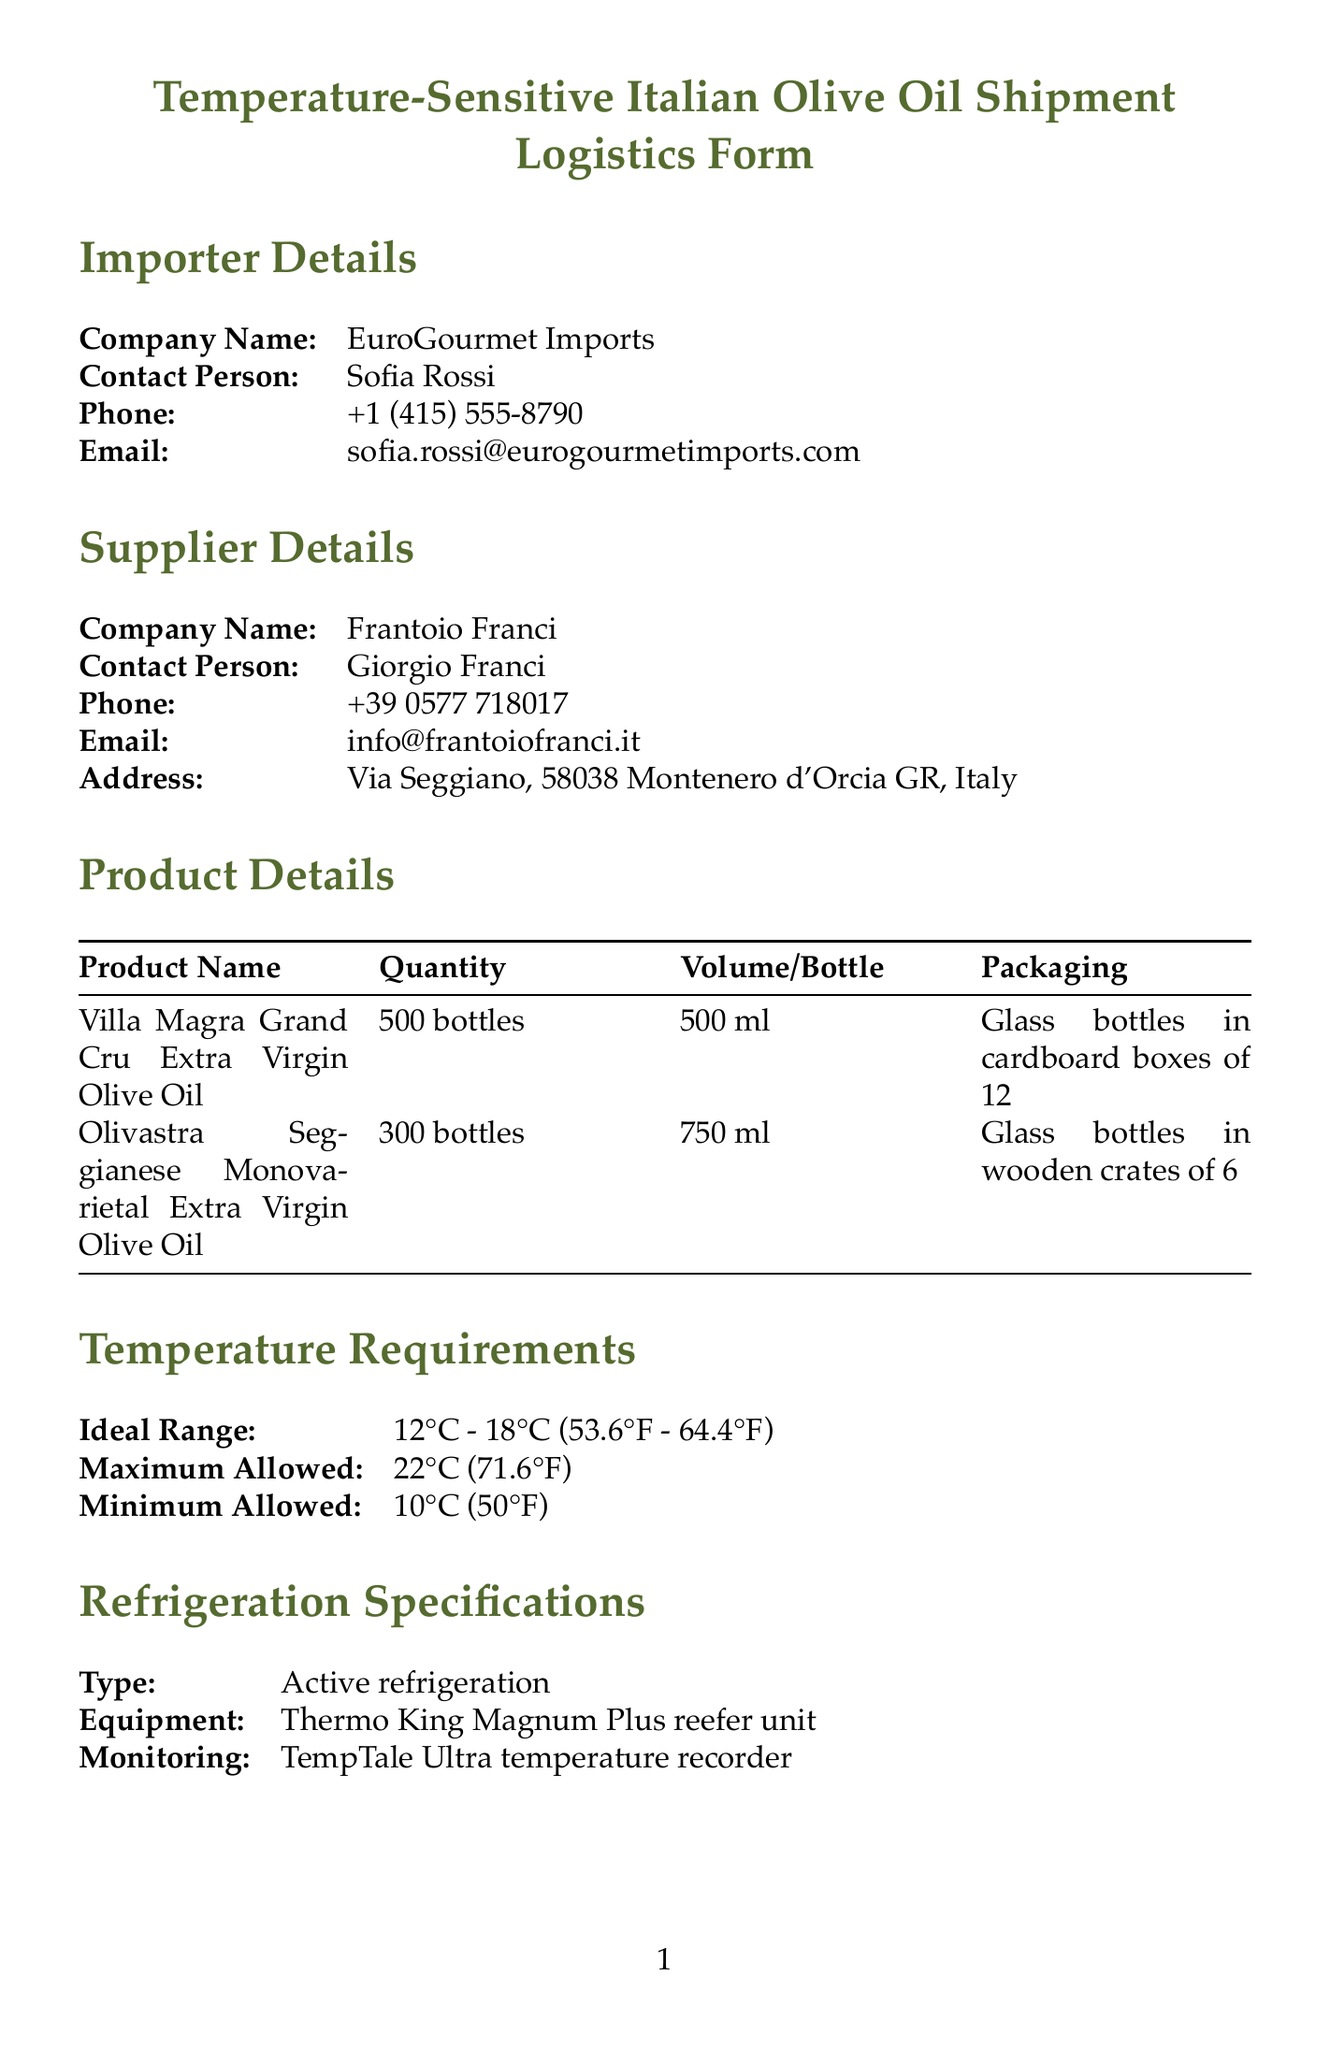What is the company name of the importer? The importer details section provides the company's name as EuroGourmet Imports.
Answer: EuroGourmet Imports Who is the contact person at the supplier's company? The supplier details section lists Giorgio Franci as the contact person.
Answer: Giorgio Franci What is the ideal temperature range for the olive oil shipment? The temperature requirements specify the ideal range as 12°C - 18°C.
Answer: 12°C - 18°C What type of refrigeration equipment is specified? The refrigeration specifications detail that a Thermo King Magnum Plus reefer unit is required.
Answer: Thermo King Magnum Plus reefer unit How many bottles of Olivastra Seggianese are included in the shipment? The product details indicate that there are 300 bottles of Olivastra Seggianese.
Answer: 300 bottles What is the estimated transit time for the shipment? The transportation details state that the estimated transit time is 21 days.
Answer: 21 days What is the HS code for the olive oil? The customs information section provides the HS code as 1509.10.
Answer: 1509.10 Which certification is required for quality control? The quality control section lists "Organic certification" as one of the required certifications.
Answer: Organic certification What is the mode of transport for the shipment? The transportation details specify that the mode of transport is sea freight.
Answer: Sea freight 